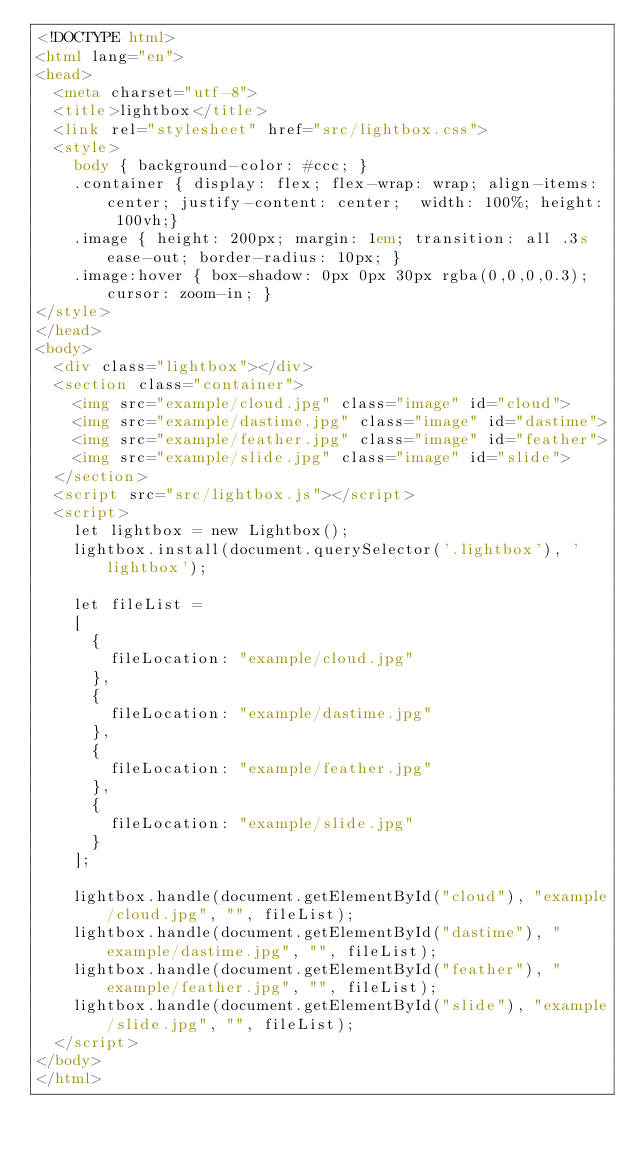<code> <loc_0><loc_0><loc_500><loc_500><_HTML_><!DOCTYPE html>
<html lang="en">
<head>
  <meta charset="utf-8">
  <title>lightbox</title>
  <link rel="stylesheet" href="src/lightbox.css">
  <style>
    body { background-color: #ccc; }
    .container { display: flex; flex-wrap: wrap; align-items: center; justify-content: center;  width: 100%; height: 100vh;}
    .image { height: 200px; margin: 1em; transition: all .3s ease-out; border-radius: 10px; }
    .image:hover { box-shadow: 0px 0px 30px rgba(0,0,0,0.3); cursor: zoom-in; }
</style>
</head>
<body>
  <div class="lightbox"></div>
  <section class="container">
    <img src="example/cloud.jpg" class="image" id="cloud">
    <img src="example/dastime.jpg" class="image" id="dastime">
    <img src="example/feather.jpg" class="image" id="feather">
    <img src="example/slide.jpg" class="image" id="slide">
  </section>
  <script src="src/lightbox.js"></script>
  <script>
    let lightbox = new Lightbox();
    lightbox.install(document.querySelector('.lightbox'), 'lightbox');

    let fileList = 
    [
      {
        fileLocation: "example/cloud.jpg"
      },
      {
        fileLocation: "example/dastime.jpg"
      },
      {
        fileLocation: "example/feather.jpg"
      },
      {
        fileLocation: "example/slide.jpg"
      }
    ];

    lightbox.handle(document.getElementById("cloud"), "example/cloud.jpg", "", fileList);
    lightbox.handle(document.getElementById("dastime"), "example/dastime.jpg", "", fileList);
    lightbox.handle(document.getElementById("feather"), "example/feather.jpg", "", fileList);
    lightbox.handle(document.getElementById("slide"), "example/slide.jpg", "", fileList);
  </script>
</body>
</html></code> 